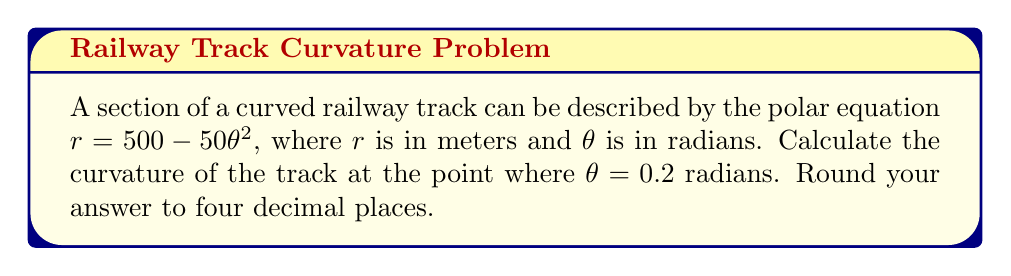Show me your answer to this math problem. To solve this problem, we'll follow these steps:

1) The curvature $\kappa$ of a curve in polar coordinates is given by the formula:

   $$\kappa = \frac{|r^2 + 2(r')^2 - rr''|}{(r^2 + (r')^2)^{3/2}}$$

   where $r'$ and $r''$ are the first and second derivatives of $r$ with respect to $\theta$.

2) First, let's find $r'$ and $r''$:
   
   $r = 500 - 50\theta^2$
   $r' = -100\theta$
   $r'' = -100$

3) Now, let's substitute $\theta = 0.2$ into these equations:

   $r = 500 - 50(0.2)^2 = 498$
   $r' = -100(0.2) = -20$
   $r'' = -100$

4) Next, we'll substitute these values into the curvature formula:

   $$\kappa = \frac{|498^2 + 2(-20)^2 - 498(-100)|}{(498^2 + (-20)^2)^{3/2}}$$

5) Simplify:

   $$\kappa = \frac{|248004 + 800 + 49800|}{(248004 + 400)^{3/2}}$$

   $$\kappa = \frac{298604}{(248404)^{3/2}}$$

6) Calculate the final result and round to four decimal places:

   $$\kappa \approx 0.0024$$
Answer: The curvature of the track at $\theta = 0.2$ radians is approximately 0.0024 m^(-1). 